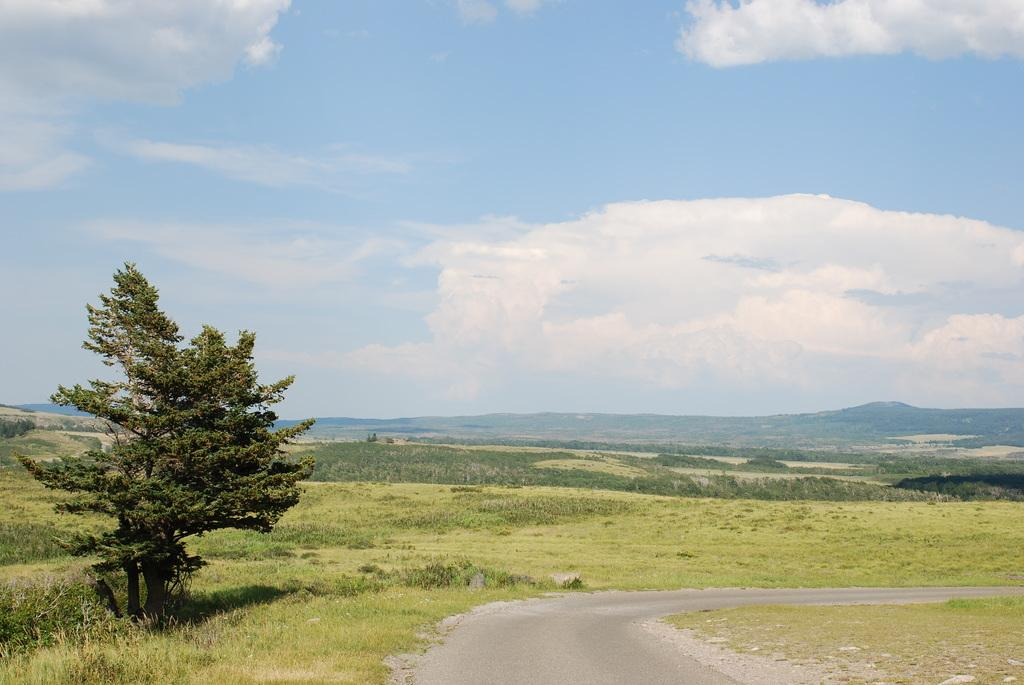What is located at the bottom of the image? There is a road at the bottom of the image. What can be seen on the left side of the image? There are trees on the left side of the image. What is visible at the top of the image? The sky is visible at the top of the image. What is the color of the sky in the image? The color of the sky is blue. Can you tell me how many creatures are depicted in the image? There are no creatures present in the image; it features a road, trees, and a blue sky. Is there a doctor in the image who can join the trees? There is no doctor present in the image, and the trees do not require joining. 